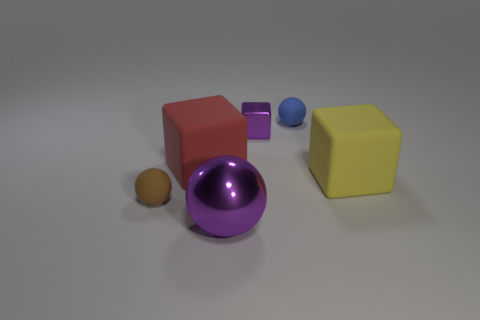Add 3 brown rubber objects. How many objects exist? 9 Subtract 0 green cubes. How many objects are left? 6 Subtract all large red matte things. Subtract all tiny spheres. How many objects are left? 3 Add 1 tiny blue things. How many tiny blue things are left? 2 Add 6 big objects. How many big objects exist? 9 